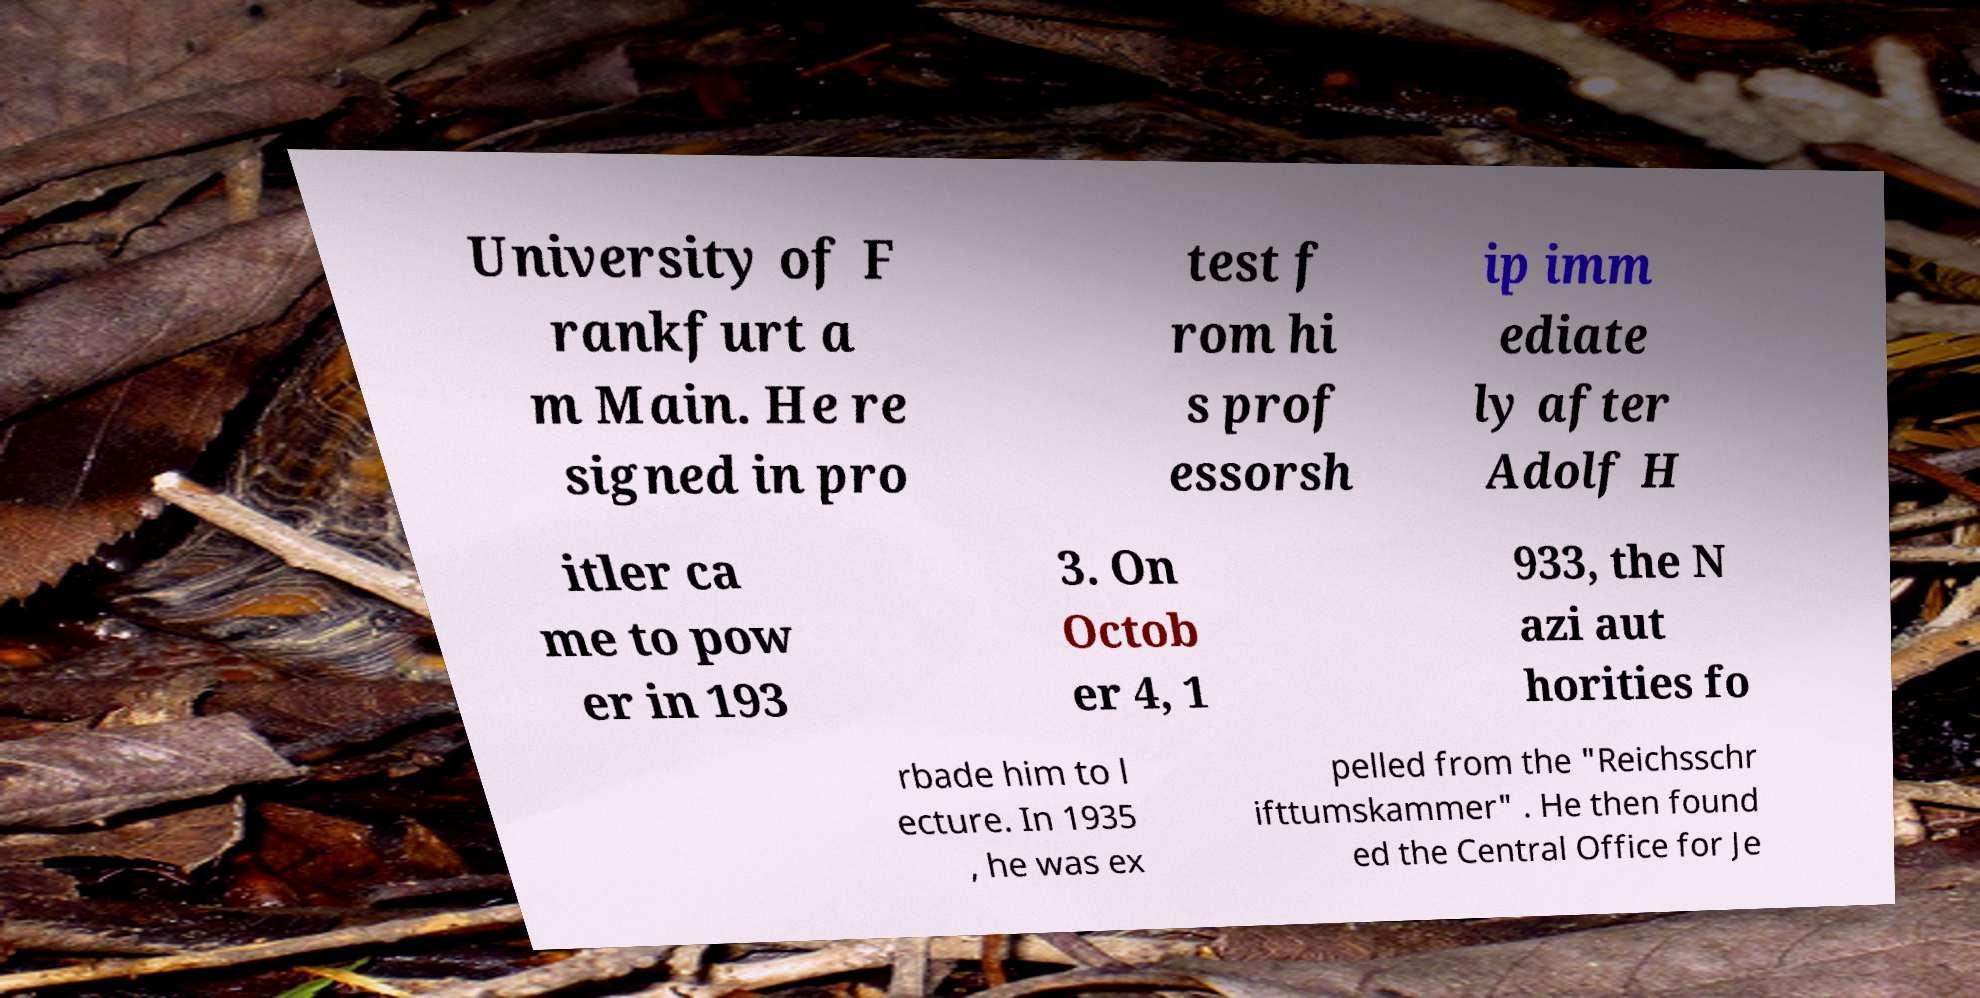Please identify and transcribe the text found in this image. University of F rankfurt a m Main. He re signed in pro test f rom hi s prof essorsh ip imm ediate ly after Adolf H itler ca me to pow er in 193 3. On Octob er 4, 1 933, the N azi aut horities fo rbade him to l ecture. In 1935 , he was ex pelled from the "Reichsschr ifttumskammer" . He then found ed the Central Office for Je 